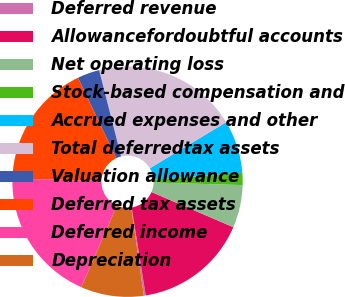<chart> <loc_0><loc_0><loc_500><loc_500><pie_chart><fcel>Deferred revenue<fcel>Allowancefordoubtful accounts<fcel>Net operating loss<fcel>Stock-based compensation and<fcel>Accrued expenses and other<fcel>Total deferredtax assets<fcel>Valuation allowance<fcel>Deferred tax assets<fcel>Deferred income<fcel>Depreciation<nl><fcel>0.26%<fcel>16.02%<fcel>5.99%<fcel>1.69%<fcel>7.42%<fcel>20.32%<fcel>3.12%<fcel>17.45%<fcel>18.88%<fcel>8.85%<nl></chart> 